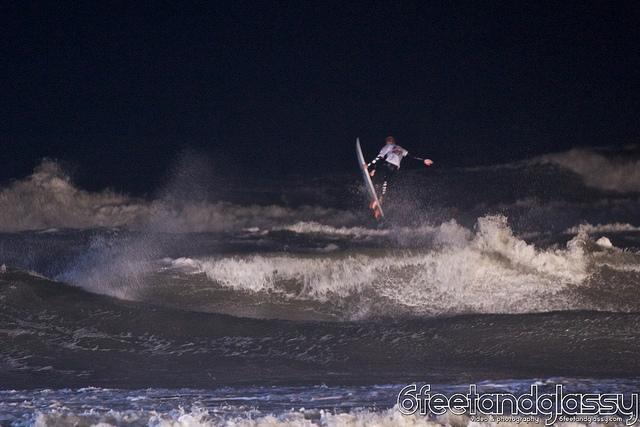How many sheep are surrounding the hay?
Give a very brief answer. 0. 